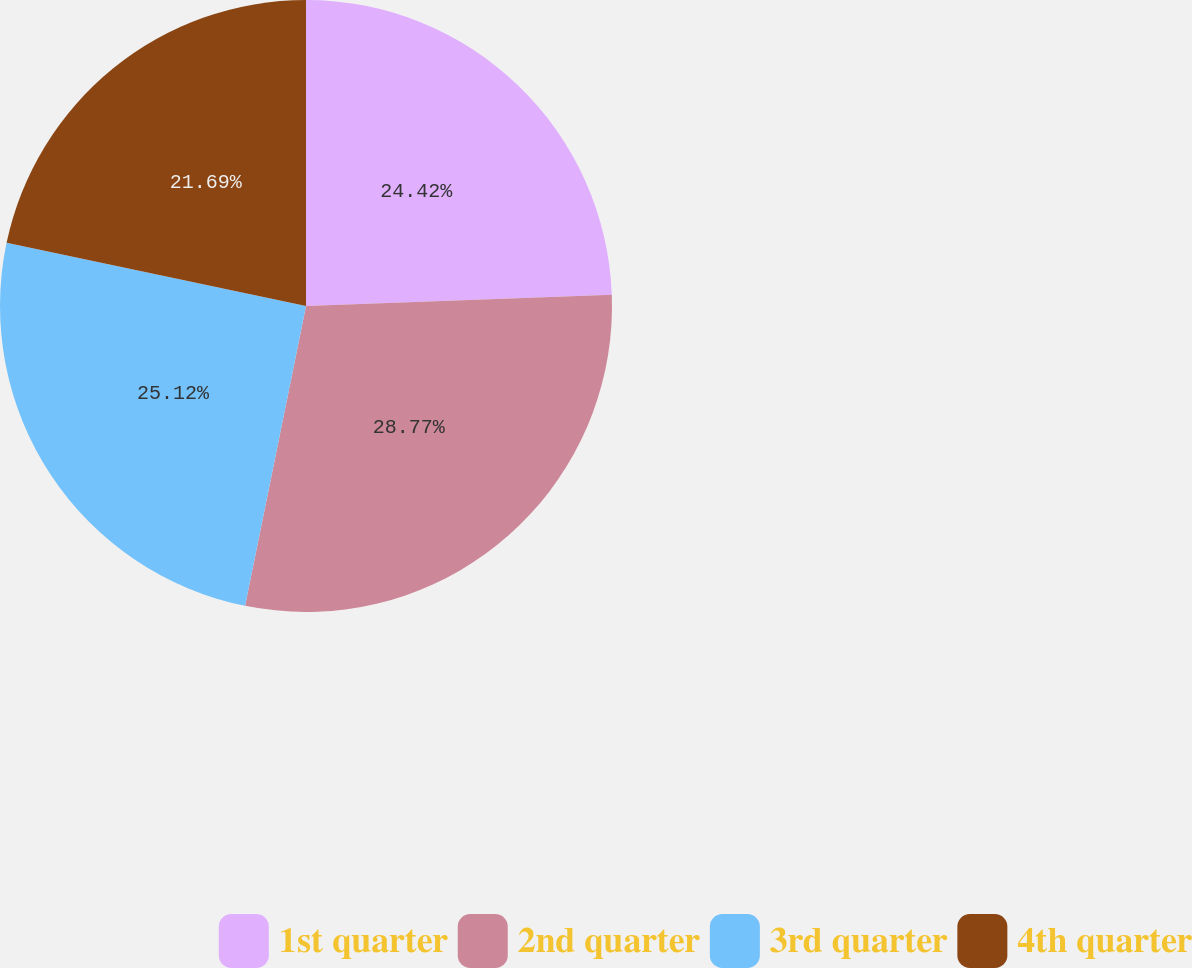Convert chart. <chart><loc_0><loc_0><loc_500><loc_500><pie_chart><fcel>1st quarter<fcel>2nd quarter<fcel>3rd quarter<fcel>4th quarter<nl><fcel>24.42%<fcel>28.77%<fcel>25.12%<fcel>21.69%<nl></chart> 